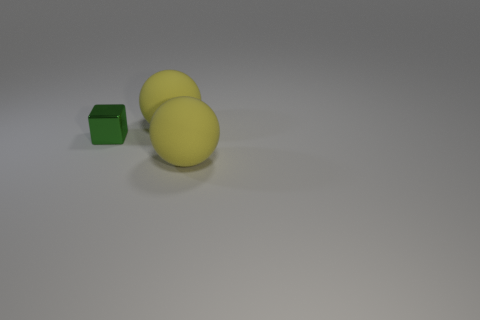Add 1 tiny green metallic objects. How many objects exist? 4 Subtract all blocks. How many objects are left? 2 Subtract 2 spheres. How many spheres are left? 0 Subtract all green spheres. Subtract all green cylinders. How many spheres are left? 2 Subtract all tiny things. Subtract all gray rubber spheres. How many objects are left? 2 Add 3 large yellow balls. How many large yellow balls are left? 5 Add 3 yellow matte balls. How many yellow matte balls exist? 5 Subtract 0 gray cylinders. How many objects are left? 3 